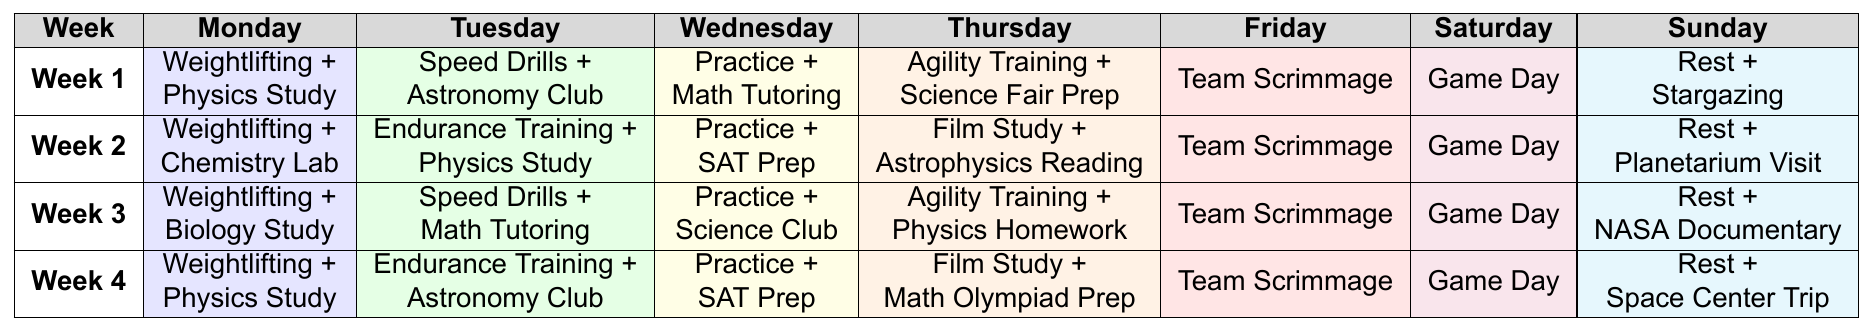What training activity is scheduled for Tuesday of Week 1? In the table, I look at the row for Week 1 and find the column for Tuesday. The entry there states "Speed Drills + Astronomy Club".
Answer: Speed Drills + Astronomy Club Which day has game day activities during the month? By examining the table, I see that "Game Day" appears in the Friday column for all four weeks, confirming that it occurs each Friday.
Answer: Every Friday What is the main focus of training on Sundays across the four weeks? I look at the Sunday column for each week. The activities shown are "Rest + Stargazing," "Rest + Planetarium Visit," "Rest + NASA Documentary," and "Rest + Space Center Trip." All focus on relaxation and astronomy-related activities.
Answer: Rest and astronomy activities Are there any endurance training sessions in the schedule? I scan through the table to find "Endurance Training." It's scheduled on Tuesday of Week 2 and Tuesday of Week 4, confirming that it is included in the training sessions.
Answer: Yes How many different study subjects are mentioned in the training schedule? I list the various subjects from the table: Physics, Astronomy, Chemistry, Math, Biology, and Science. This gives a total of six unique subjects.
Answer: Six Which week has both "Team Scrimmage" and "Game Day" on the same days? In the table, I check each week, finding that each week has "Team Scrimmage" on Friday and "Game Day" also on Friday. Therefore, all weeks have these on the same day.
Answer: Every week What is the primary focus of the training on Wednesdays across the weeks? I review the Wednesday entries across all weeks: "Practice + Math Tutoring," "Practice + SAT Prep," "Practice + Science Club," and "Practice + SAT Prep." Most activities focus on practice and academic support.
Answer: Practice and academic support In which week is the Science Fair Prep scheduled? Looking at the table, Science Fair Prep is listed under the Thursday column in Week 1.
Answer: Week 1 What activity is paired with weightlifting in Week 2? I refer to Week 2 in the table, where the Monday activity shows "Weightlifting + Chemistry Lab."
Answer: Chemistry Lab Which week contains an "Astrophysics Reading" session? In the table, I find that "Astrophysics Reading" is scheduled for Thursday of Week 2 under Film Study.
Answer: Week 2 